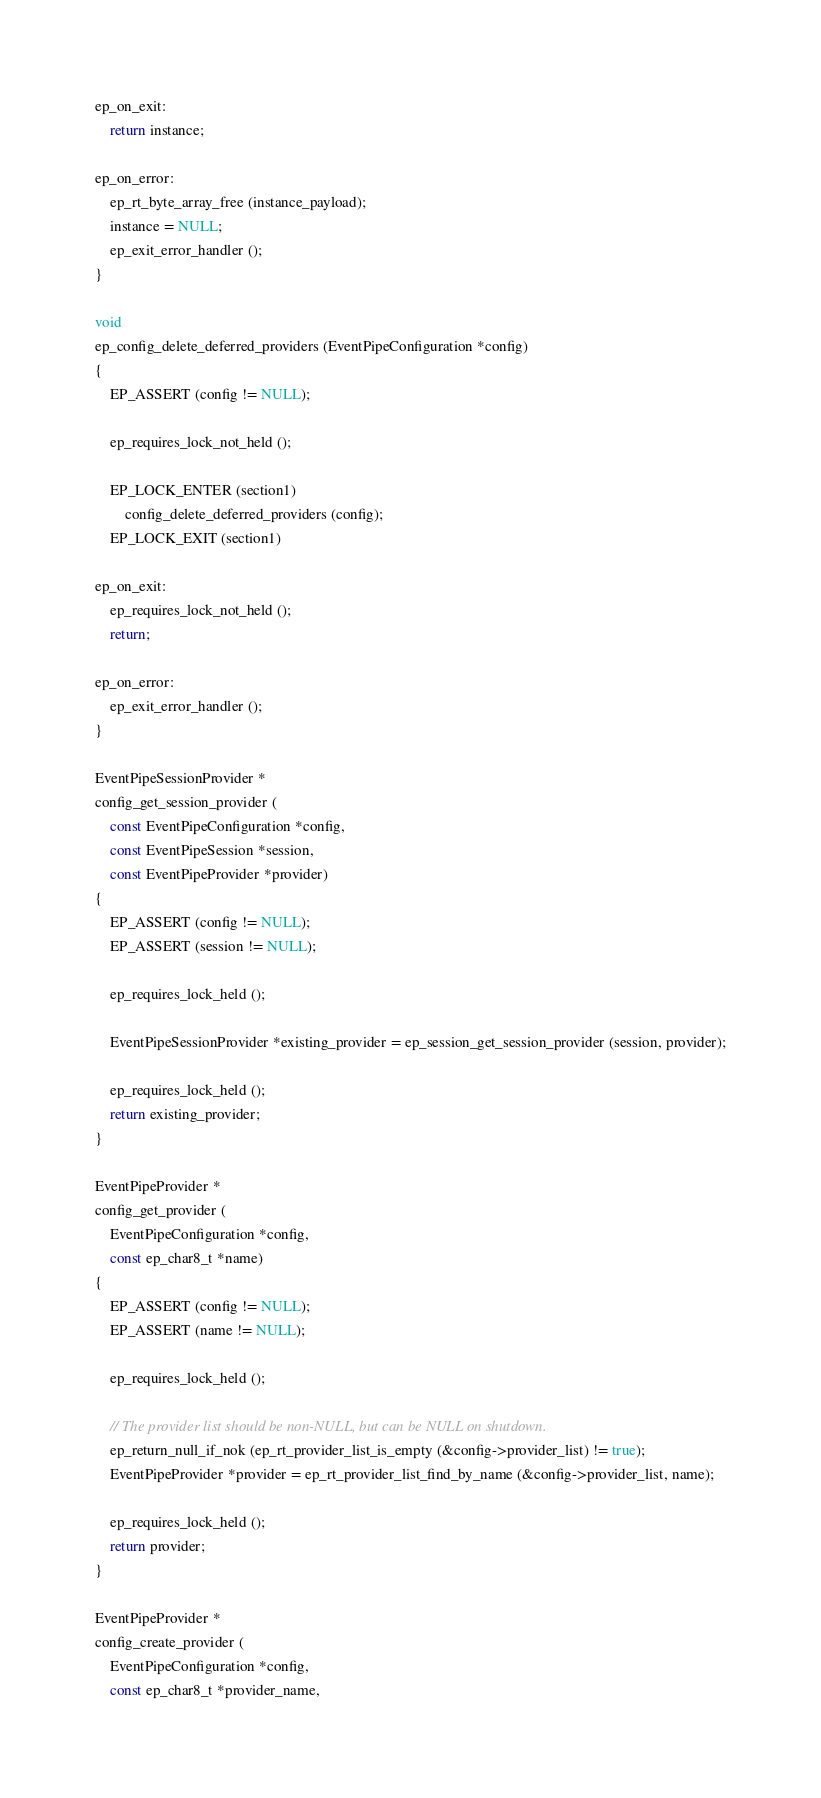<code> <loc_0><loc_0><loc_500><loc_500><_C_>
ep_on_exit:
	return instance;

ep_on_error:
	ep_rt_byte_array_free (instance_payload);
	instance = NULL;
	ep_exit_error_handler ();
}

void
ep_config_delete_deferred_providers (EventPipeConfiguration *config)
{
	EP_ASSERT (config != NULL);

	ep_requires_lock_not_held ();

	EP_LOCK_ENTER (section1)
		config_delete_deferred_providers (config);
	EP_LOCK_EXIT (section1)

ep_on_exit:
	ep_requires_lock_not_held ();
	return;

ep_on_error:
	ep_exit_error_handler ();
}

EventPipeSessionProvider *
config_get_session_provider (
	const EventPipeConfiguration *config,
	const EventPipeSession *session,
	const EventPipeProvider *provider)
{
	EP_ASSERT (config != NULL);
	EP_ASSERT (session != NULL);

	ep_requires_lock_held ();

	EventPipeSessionProvider *existing_provider = ep_session_get_session_provider (session, provider);

	ep_requires_lock_held ();
	return existing_provider;
}

EventPipeProvider *
config_get_provider (
	EventPipeConfiguration *config,
	const ep_char8_t *name)
{
	EP_ASSERT (config != NULL);
	EP_ASSERT (name != NULL);

	ep_requires_lock_held ();

	// The provider list should be non-NULL, but can be NULL on shutdown.
	ep_return_null_if_nok (ep_rt_provider_list_is_empty (&config->provider_list) != true);
	EventPipeProvider *provider = ep_rt_provider_list_find_by_name (&config->provider_list, name);

	ep_requires_lock_held ();
	return provider;
}

EventPipeProvider *
config_create_provider (
	EventPipeConfiguration *config,
	const ep_char8_t *provider_name,</code> 